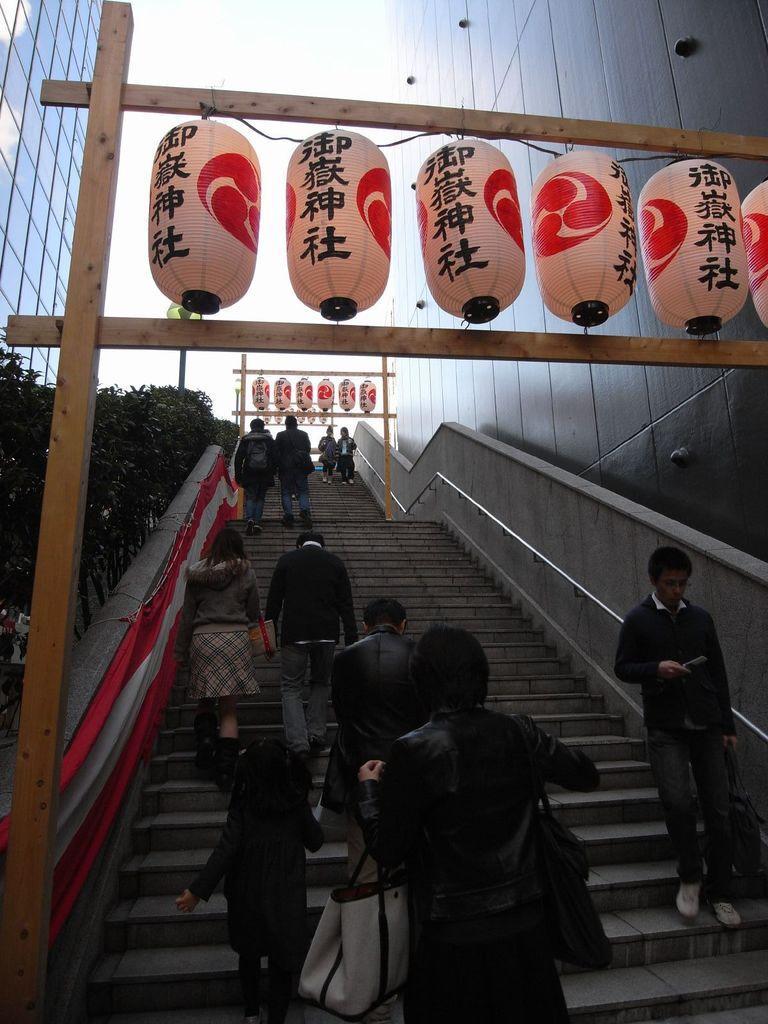Describe this image in one or two sentences. In this picture I can see the steps in front, on which there are number of people and in the center of this picture I can see the wooden things and I see few Chinese lanterns and I see something is written on it. In the background I can see a building, few plants and few more Chinese lanterns. 